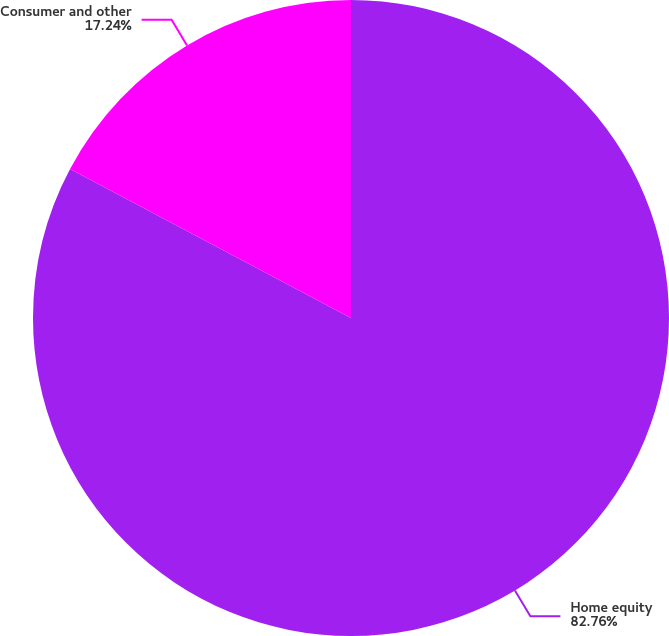Convert chart. <chart><loc_0><loc_0><loc_500><loc_500><pie_chart><fcel>Home equity<fcel>Consumer and other<nl><fcel>82.76%<fcel>17.24%<nl></chart> 